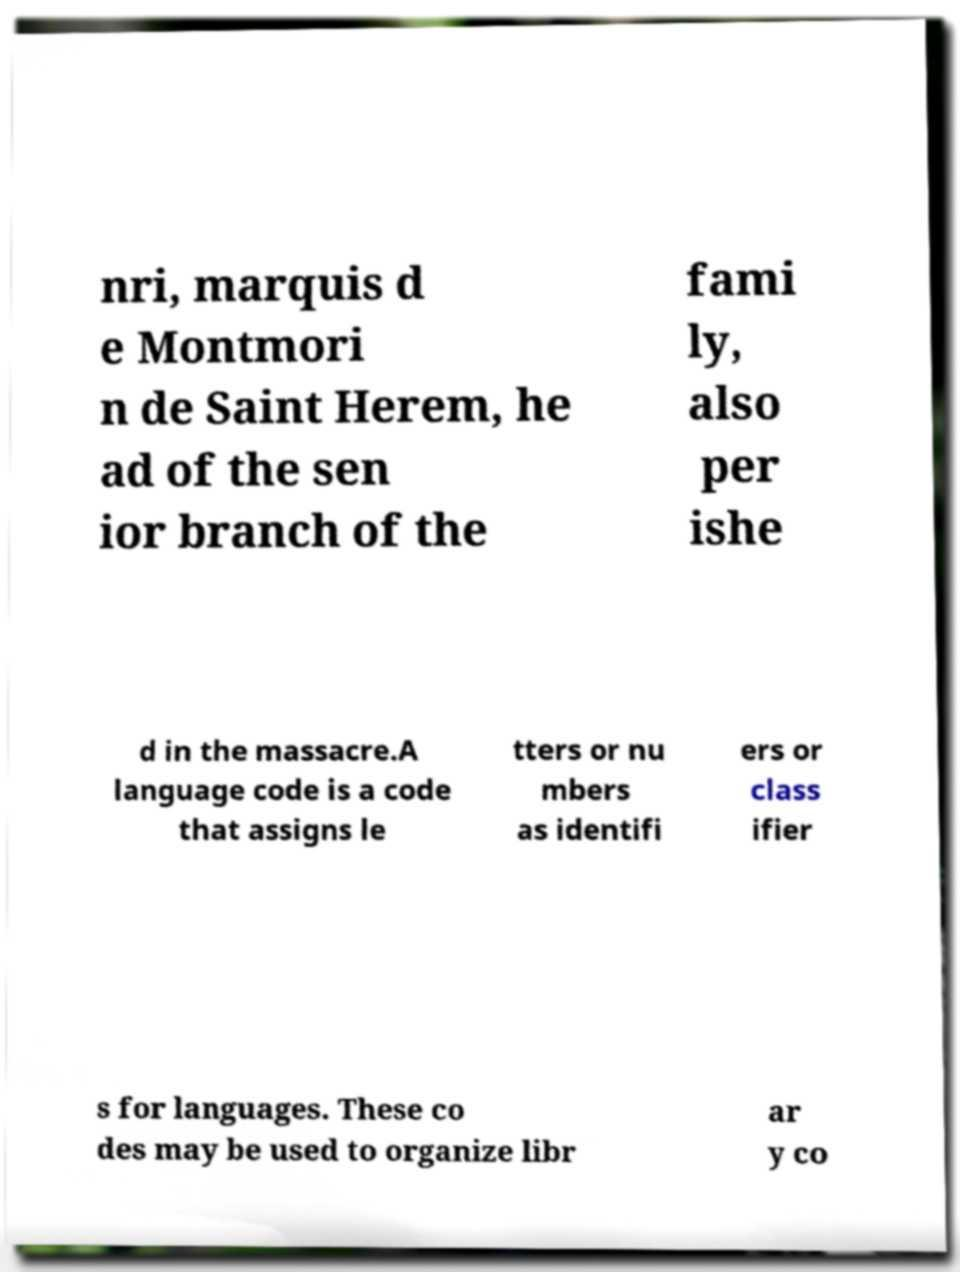Could you assist in decoding the text presented in this image and type it out clearly? nri, marquis d e Montmori n de Saint Herem, he ad of the sen ior branch of the fami ly, also per ishe d in the massacre.A language code is a code that assigns le tters or nu mbers as identifi ers or class ifier s for languages. These co des may be used to organize libr ar y co 